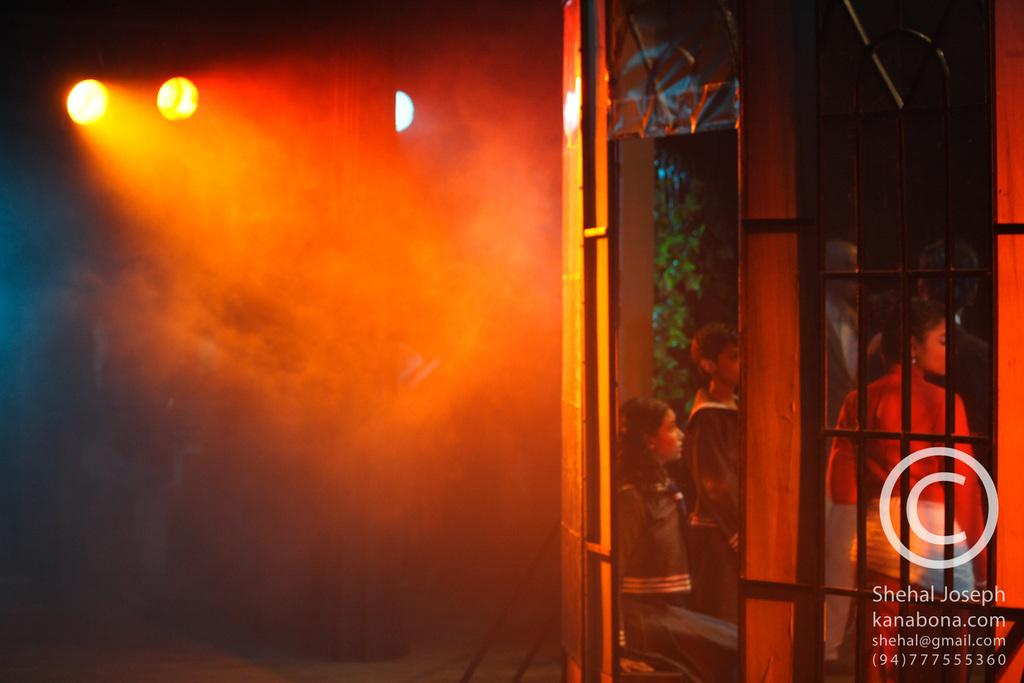What can be seen on the left side of the image? There are lights on the left side of the image. What type of wall is on the right side of the image? There is a glass wall on the right side of the image. What is happening behind the glass wall? There are people standing behind the glass wall. Who is the creator of the sand visible in the image? There is no sand present in the image, so it is not possible to determine the creator. 